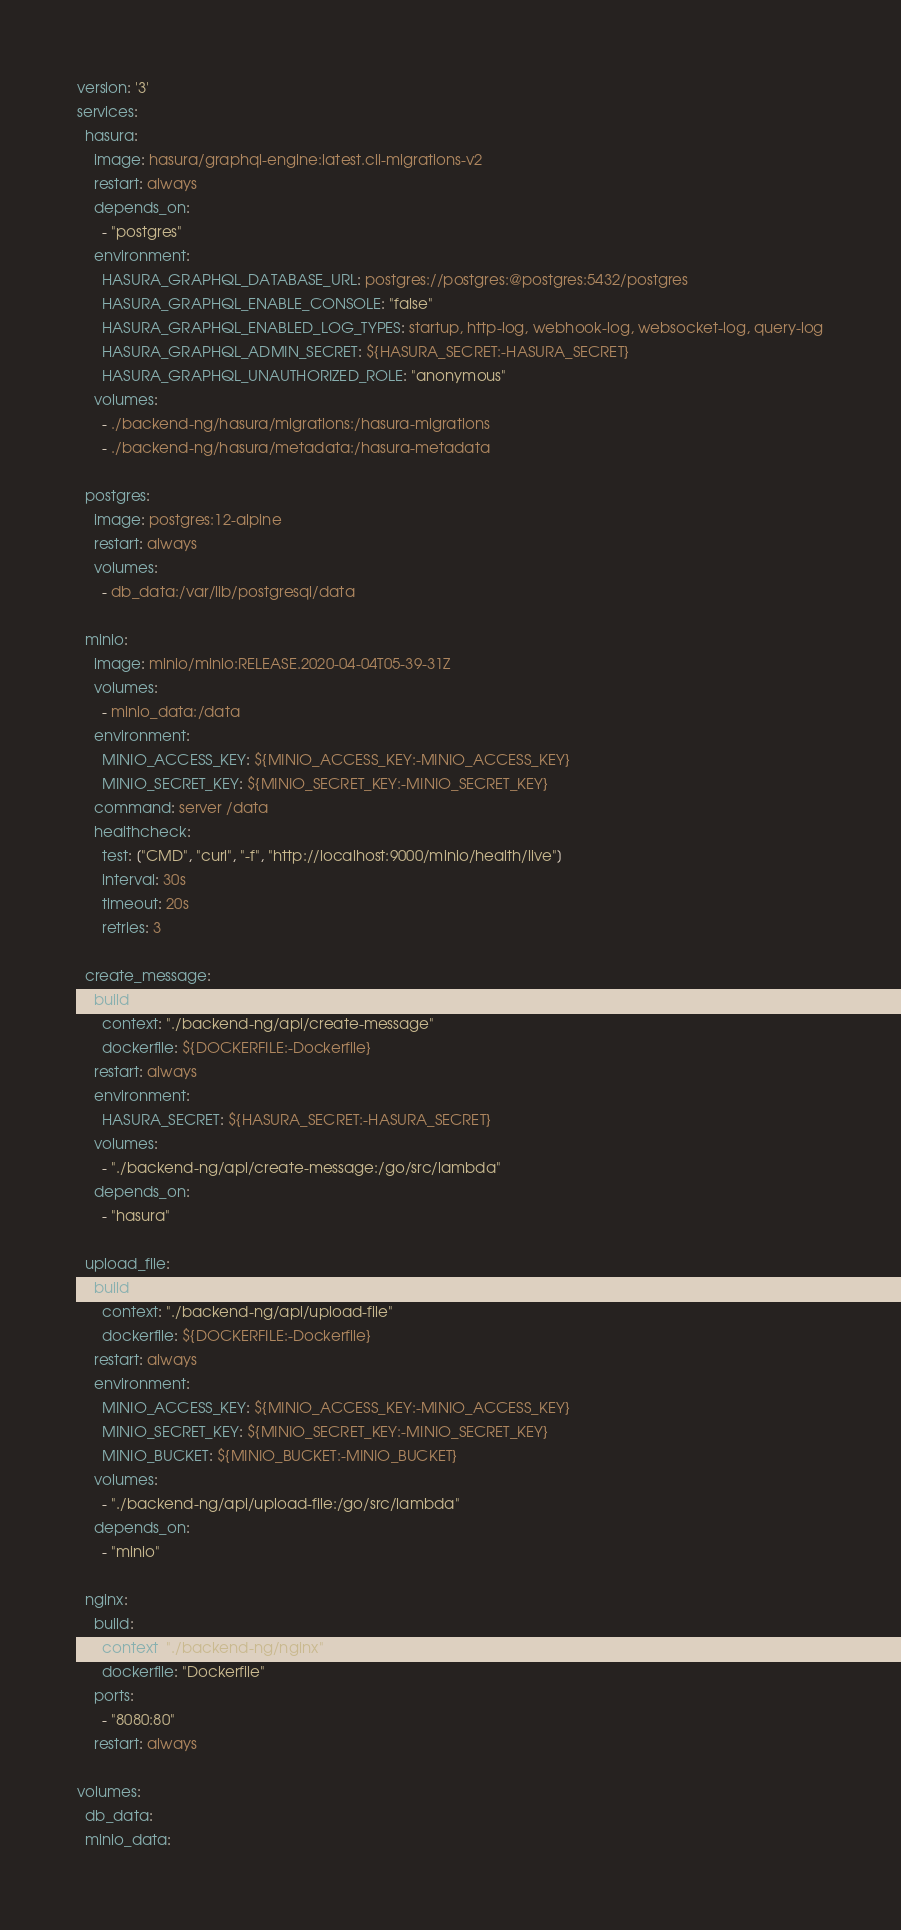Convert code to text. <code><loc_0><loc_0><loc_500><loc_500><_YAML_>version: '3'
services:
  hasura:
    image: hasura/graphql-engine:latest.cli-migrations-v2
    restart: always
    depends_on:
      - "postgres"
    environment:
      HASURA_GRAPHQL_DATABASE_URL: postgres://postgres:@postgres:5432/postgres
      HASURA_GRAPHQL_ENABLE_CONSOLE: "false"
      HASURA_GRAPHQL_ENABLED_LOG_TYPES: startup, http-log, webhook-log, websocket-log, query-log
      HASURA_GRAPHQL_ADMIN_SECRET: ${HASURA_SECRET:-HASURA_SECRET}
      HASURA_GRAPHQL_UNAUTHORIZED_ROLE: "anonymous"
    volumes:
      - ./backend-ng/hasura/migrations:/hasura-migrations
      - ./backend-ng/hasura/metadata:/hasura-metadata

  postgres:
    image: postgres:12-alpine
    restart: always
    volumes:
      - db_data:/var/lib/postgresql/data

  minio:
    image: minio/minio:RELEASE.2020-04-04T05-39-31Z
    volumes:
      - minio_data:/data
    environment:
      MINIO_ACCESS_KEY: ${MINIO_ACCESS_KEY:-MINIO_ACCESS_KEY}
      MINIO_SECRET_KEY: ${MINIO_SECRET_KEY:-MINIO_SECRET_KEY}
    command: server /data
    healthcheck:
      test: ["CMD", "curl", "-f", "http://localhost:9000/minio/health/live"]
      interval: 30s
      timeout: 20s
      retries: 3

  create_message:
    build:
      context: "./backend-ng/api/create-message"
      dockerfile: ${DOCKERFILE:-Dockerfile}
    restart: always
    environment:
      HASURA_SECRET: ${HASURA_SECRET:-HASURA_SECRET}
    volumes:
      - "./backend-ng/api/create-message:/go/src/lambda"
    depends_on:
      - "hasura"

  upload_file:
    build:
      context: "./backend-ng/api/upload-file"
      dockerfile: ${DOCKERFILE:-Dockerfile}
    restart: always
    environment:
      MINIO_ACCESS_KEY: ${MINIO_ACCESS_KEY:-MINIO_ACCESS_KEY}
      MINIO_SECRET_KEY: ${MINIO_SECRET_KEY:-MINIO_SECRET_KEY}
      MINIO_BUCKET: ${MINIO_BUCKET:-MINIO_BUCKET}
    volumes:
      - "./backend-ng/api/upload-file:/go/src/lambda"
    depends_on:
      - "minio"

  nginx:
    build:
      context: "./backend-ng/nginx"
      dockerfile: "Dockerfile"
    ports:
      - "8080:80"
    restart: always

volumes:
  db_data:
  minio_data:
</code> 